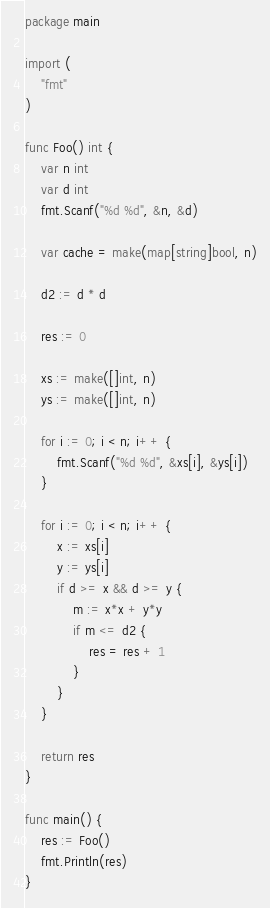Convert code to text. <code><loc_0><loc_0><loc_500><loc_500><_Go_>package main

import (
	"fmt"
)

func Foo() int {
	var n int
	var d int
	fmt.Scanf("%d %d", &n, &d)

	var cache = make(map[string]bool, n)

	d2 := d * d

	res := 0

	xs := make([]int, n)
	ys := make([]int, n)

	for i := 0; i < n; i++ {
		fmt.Scanf("%d %d", &xs[i], &ys[i])
	}

	for i := 0; i < n; i++ {
		x := xs[i]
		y := ys[i]
		if d >= x && d >= y {
			m := x*x + y*y
			if m <= d2 {
				res = res + 1
			}
		}
	}

	return res
}

func main() {
	res := Foo()
	fmt.Println(res)
}
</code> 